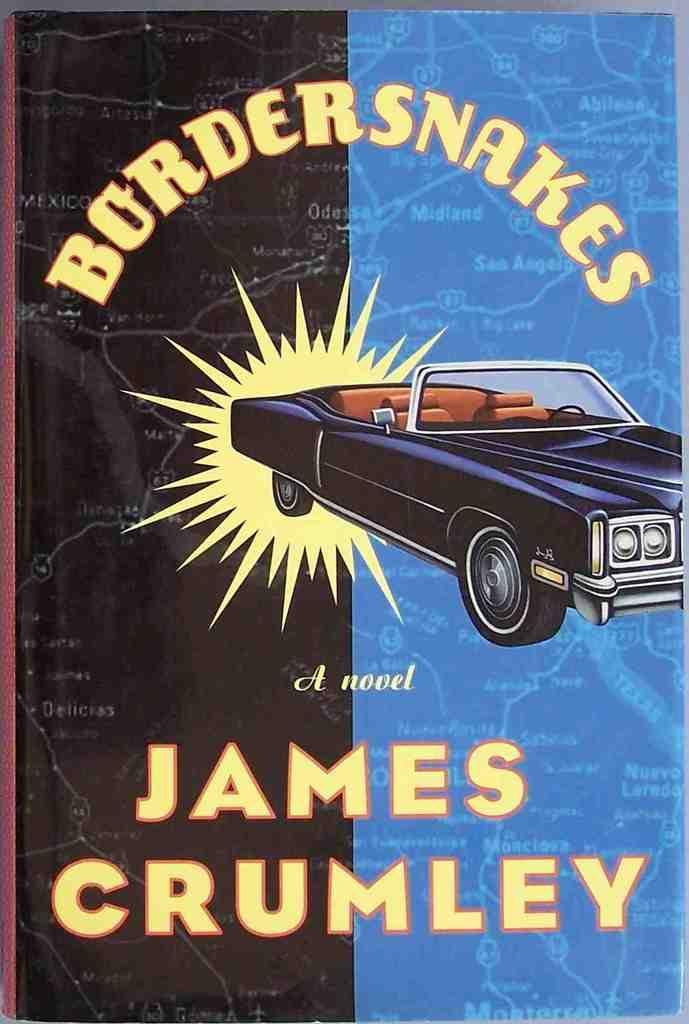What is the main subject of the poster in the image? The poster features a car. Can you describe the poster in the image? There is a poster in the image, and it features a car. How many girls are sitting on the glass in the image? There are no girls or glass present in the image; it only features a poster with a car. 